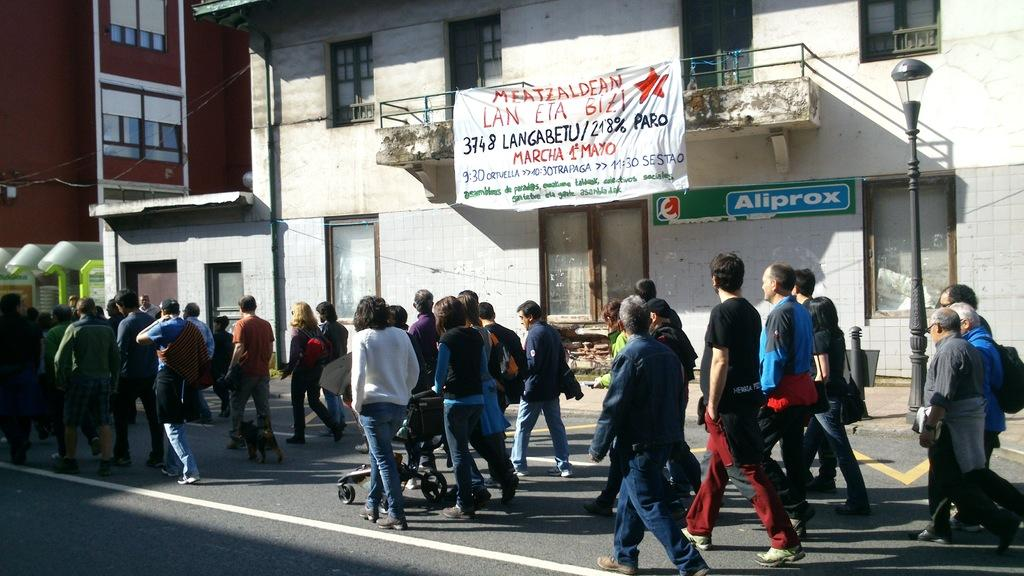What type of structures are visible in the image? There are buildings in the image. What are the people in the image doing? There are persons walking on the road in the image. What is hanging at the top of the image? There is a banner at the top of the image. What can be seen on the right side of the image? There is a street pole on the right side of the image. Can you see an office building near the lake in the image? There is no office building or lake present in the image. What type of observation can be made about the people walking on the road in the image? There is no specific observation about the people walking on the road mentioned in the provided facts. 